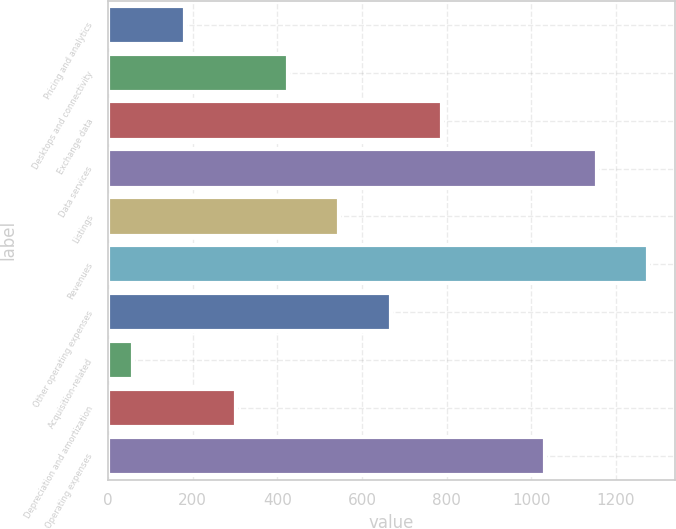Convert chart to OTSL. <chart><loc_0><loc_0><loc_500><loc_500><bar_chart><fcel>Pricing and analytics<fcel>Desktops and connectivity<fcel>Exchange data<fcel>Data services<fcel>Listings<fcel>Revenues<fcel>Other operating expenses<fcel>Acquisition-related<fcel>Depreciation and amortization<fcel>Operating expenses<nl><fcel>181.6<fcel>424.8<fcel>789.6<fcel>1154.4<fcel>546.4<fcel>1276<fcel>668<fcel>60<fcel>303.2<fcel>1032.8<nl></chart> 